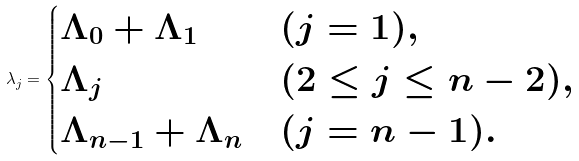<formula> <loc_0><loc_0><loc_500><loc_500>\lambda _ { j } = \begin{cases} \Lambda _ { 0 } + \Lambda _ { 1 } & ( j = 1 ) , \\ \Lambda _ { j } & ( 2 \leq j \leq n - 2 ) , \\ \Lambda _ { n - 1 } + \Lambda _ { n } & ( j = n - 1 ) . \end{cases}</formula> 